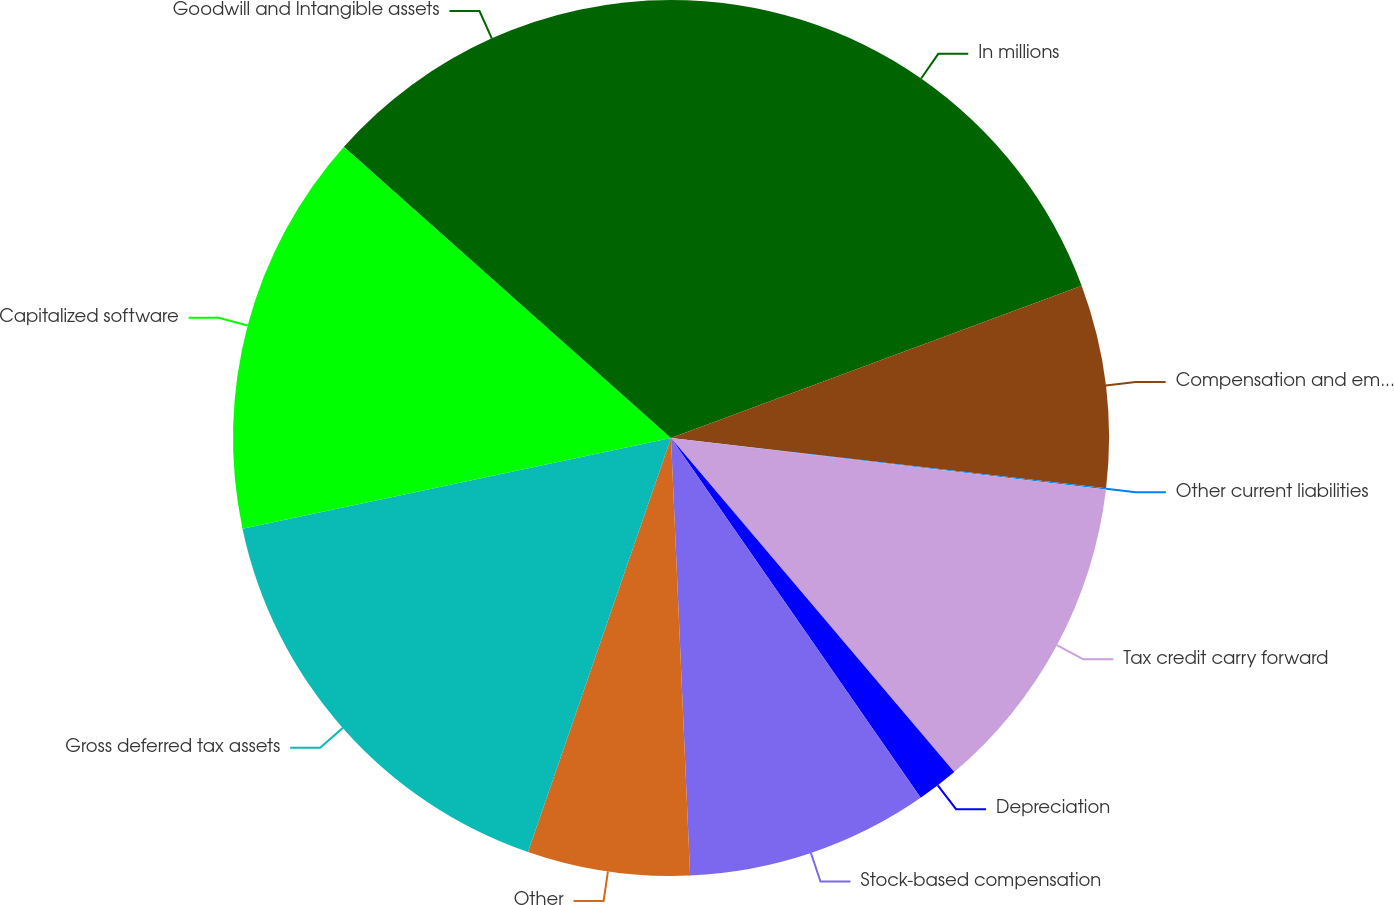Convert chart. <chart><loc_0><loc_0><loc_500><loc_500><pie_chart><fcel>In millions<fcel>Compensation and employee<fcel>Other current liabilities<fcel>Tax credit carry forward<fcel>Depreciation<fcel>Stock-based compensation<fcel>Other<fcel>Gross deferred tax assets<fcel>Capitalized software<fcel>Goodwill and Intangible assets<nl><fcel>19.35%<fcel>7.48%<fcel>0.05%<fcel>11.93%<fcel>1.54%<fcel>8.96%<fcel>5.99%<fcel>16.39%<fcel>14.9%<fcel>13.42%<nl></chart> 